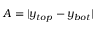<formula> <loc_0><loc_0><loc_500><loc_500>A = | y _ { t o p } - y _ { b o t } |</formula> 